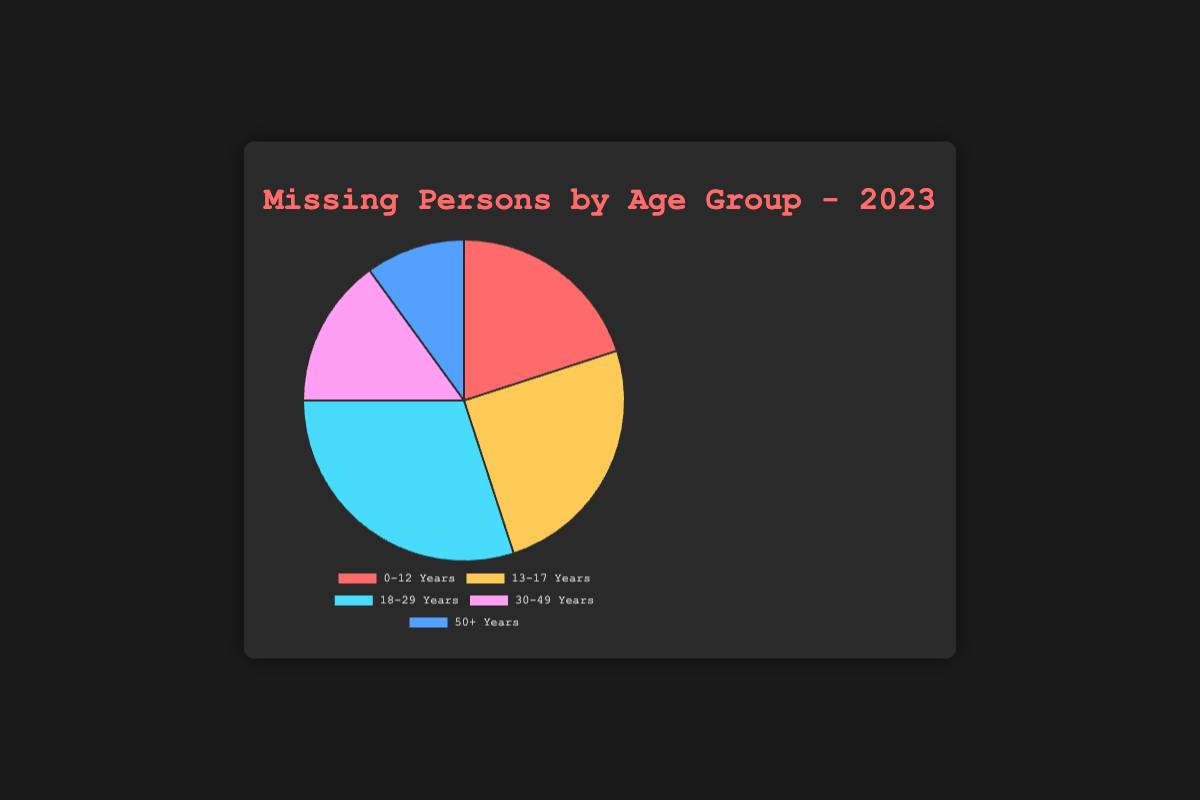What is the largest age group of missing persons in 2023? The pie chart shows each age group's proportion of missing persons. The 18-29 Years group has the largest section.
Answer: 18-29 Years Which age group has the second highest number of missing persons? By visual inspection, the second largest section of the pie is for the 13-17 Years age group.
Answer: 13-17 Years How does the number of missing persons in the 30-49 Years group compare to the 50 Plus Years group? The pie chart shows that the 30-49 Years group has a larger section compared to the 50 Plus Years group.
Answer: 30-49 Years > 50 Plus Years What's the total number of missing persons in the age groups below 18 years? Add the numbers from the 0-12 Years (20) and 13-17 Years (25) age groups: 20 + 25.
Answer: 45 Is there an equal number of missing persons between any two age groups? By inspecting the pie chart, no two groups have equal sections. The values are 20, 25, 30, 15, and 10.
Answer: No Which color represents the 50 Plus Years age group? The pie chart shows the 50 Plus Years group in a specific color. The color for this group is identified as blue.
Answer: Blue What is the sum of missing persons in the 18-29 Years and 30-49 Years groups? To find the sum, add the values of the 18-29 Years (30) and 30-49 Years (15) groups: 30 + 15.
Answer: 45 What percentage of missing persons are aged 0-12 Years? To find the percentage, divide the 0-12 Years number (20) by the total (100) and multiply by 100: (20/100) * 100.
Answer: 20% What is the difference between the number of missing persons in the 13-17 Years group and the 50 Plus Years group? Subtract the number in the 50 Plus Years group (10) from the 13-17 Years group (25): 25 - 10.
Answer: 15 What is the least represented age group in the pie chart? The smallest section in the pie chart corresponds to the 50 Plus Years group.
Answer: 50 Plus Years 